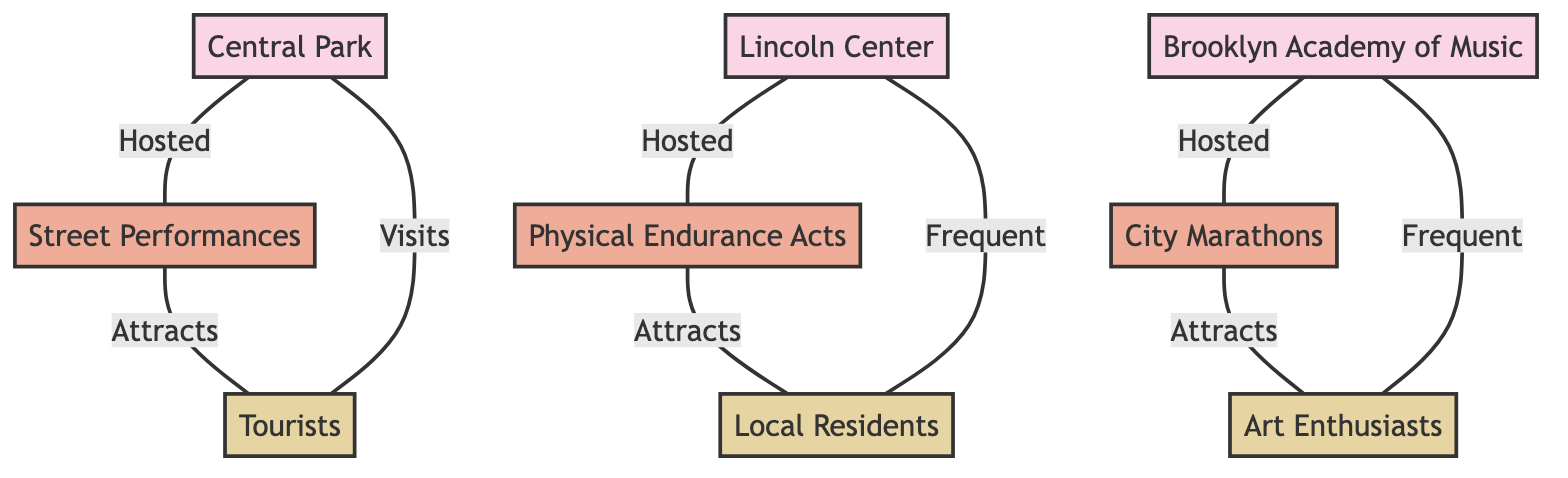What venues host Street Performances? To answer this question, we look for the node labeled "Street Performances" and trace the edges connected to it. The edge from "Central Park" to "Street Performances" indicates that "Central Park" hosts this performance type.
Answer: Central Park Which audience type frequents Brooklyn Academy of Music? We check the connections for "Brooklyn Academy of Music" and identify the edge that indicates which audience type's relationship is "Frequent". The edge leads to "Art Enthusiasts".
Answer: Art Enthusiasts How many edges are in the diagram? To determine the number of edges, we can count all the connections represented in the relationship mappings. There are a total of 8 edges present.
Answer: 8 What type of performances are hosted at Lincoln Center? We identify the edge that connects "Lincoln Center" to its corresponding performance type. The edge shows that "Physical Endurance Acts" is hosted at this venue.
Answer: Physical Endurance Acts Which audience visits Central Park? We need to trace the edges connected to "Central Park" and pick the one that is labeled "Visits". The edge connects "Tourists" to "Central Park".
Answer: Tourists Which venue attracts Local Residents? We look at the edges for the audience type "Local Residents" and check for connections related to the "Attracts" relationship. The connection leads to "Physical Endurance Acts", which is hosted at Lincoln Center. Starting from here, we find that this performance type attracts "Local Residents".
Answer: Lincoln Center What is the total number of venues in this diagram? We can count all the nodes classified as "Venue". There are 3 venues listed: Central Park, Lincoln Center, and Brooklyn Academy of Music.
Answer: 3 Which performance type attracts Tourists? We identify the audience type "Tourists" and look at the relationships to find which performance type attracts them. The edge indicates that "Street Performances" attracts "Tourists".
Answer: Street Performances What is the connection type between City Marathons and Art Enthusiasts? We check the diagram for the connection going from "City Marathons" to its audience. The edge shows that Art Enthusiasts are attracted to City Marathons. The relationship type is "Attracts".
Answer: Attracts 